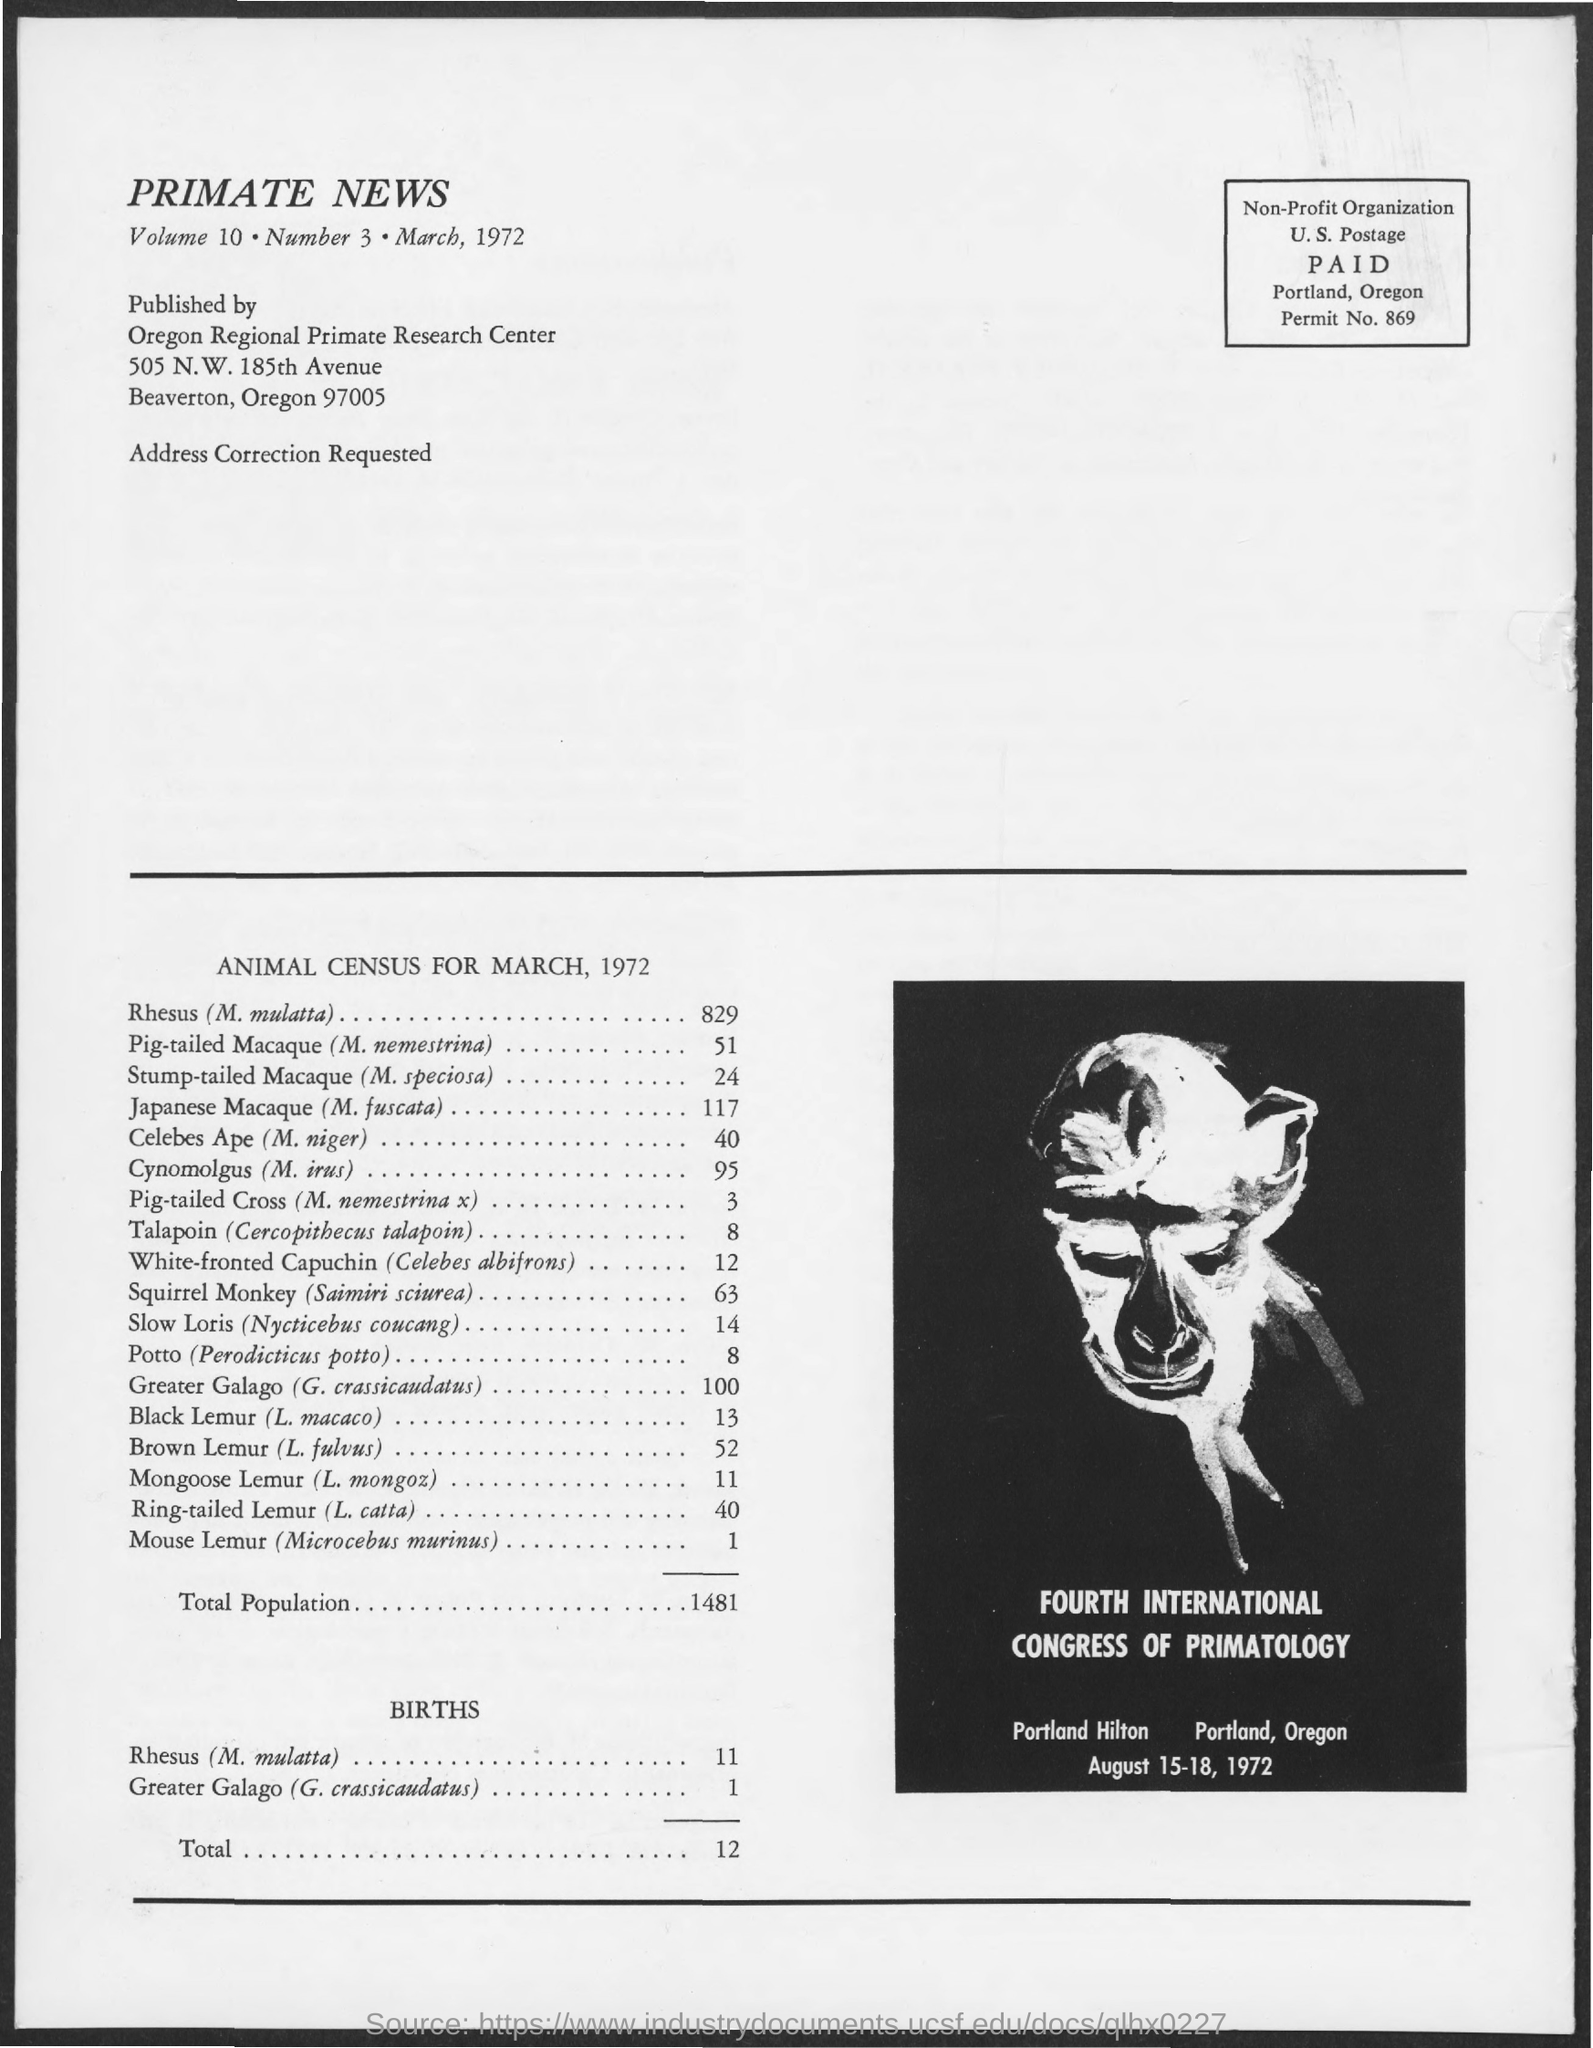Outline some significant characteristics in this image. The Fourth International Congress of Primatology was held on August 15-18, 1972. According to the animal census conducted in March 1972, the total population was 1481. The permit number provided in this document is 869. The document provides a census of Cynomolgus (M. irus) with a count of 95. According to the document, the census of Rhesus (M. mulatta) is 829. 